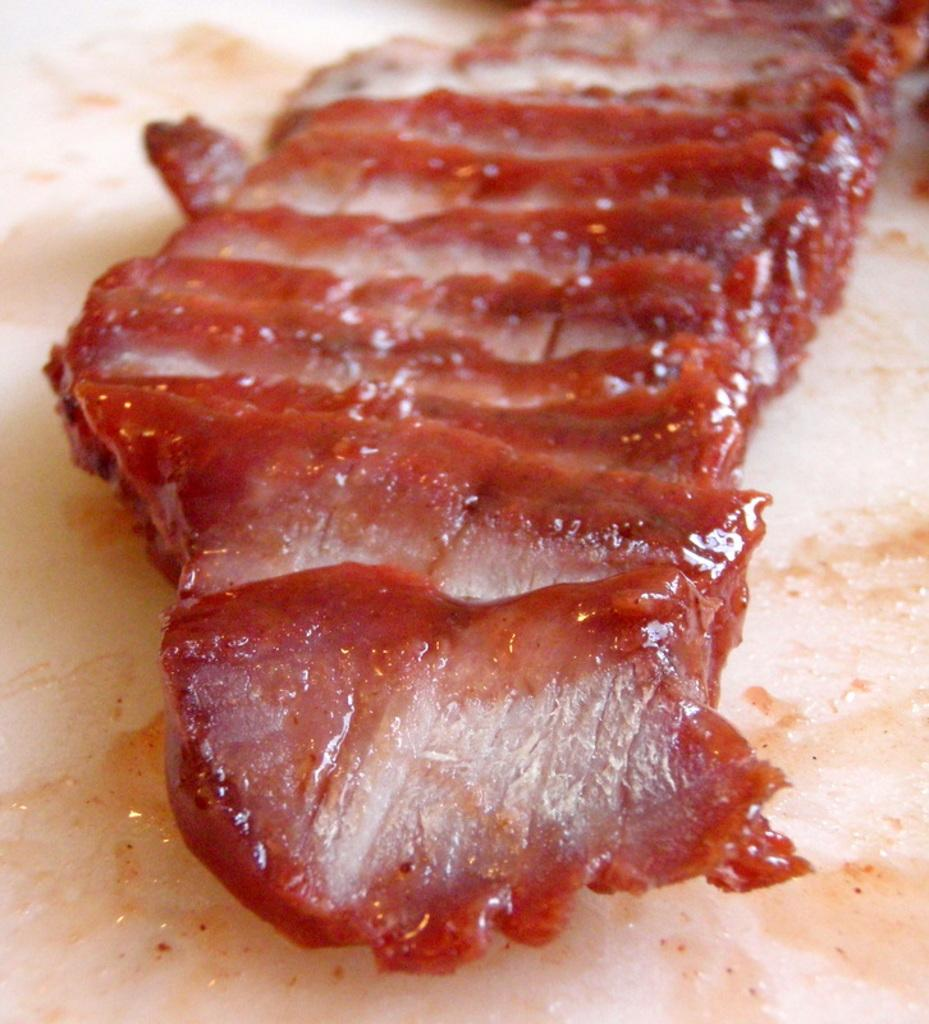What is on the plate that is visible in the image? There is meat on a plate in the image. Where is the plate located in the image? The plate is located in the center of the image. What type of cart is being used to transport the meat in the image? There is no cart present in the image; it only shows a plate of meat. 